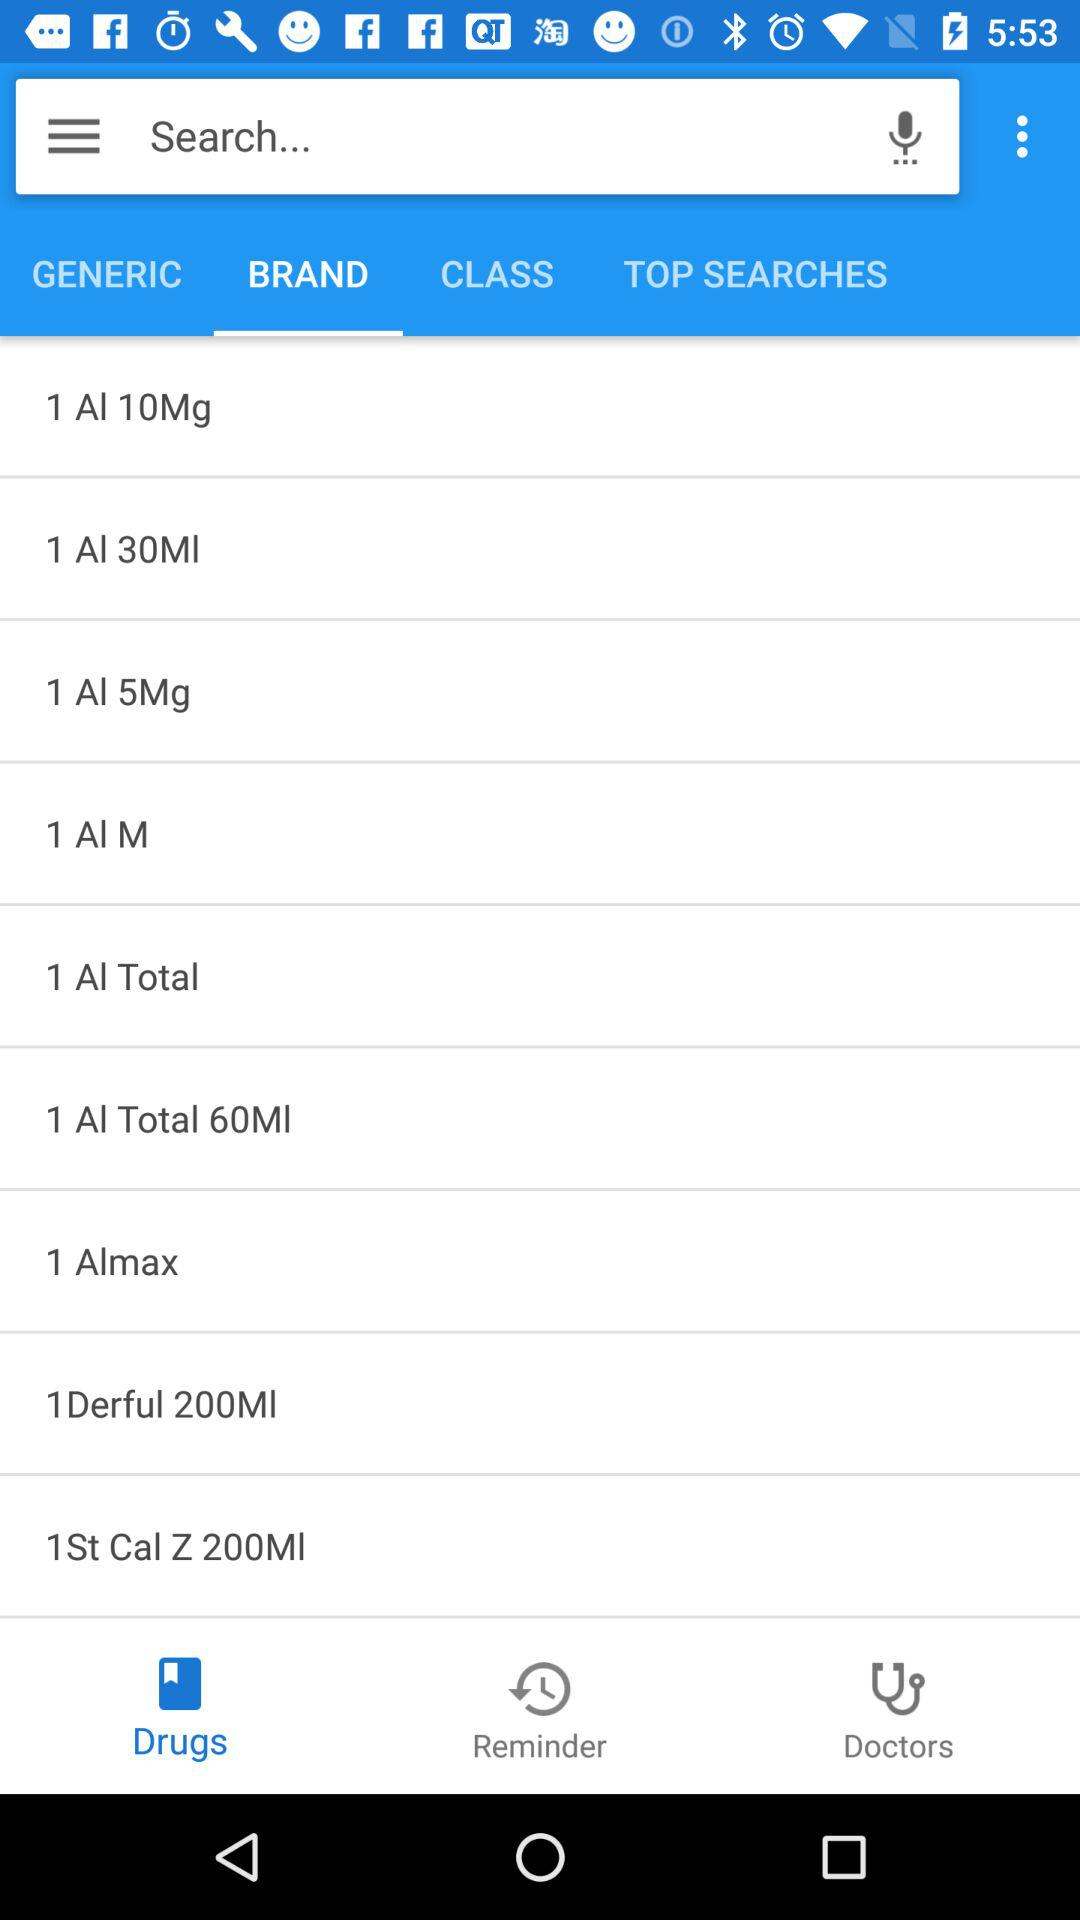Which tab is selected? The tab "BRAND" is selected. 